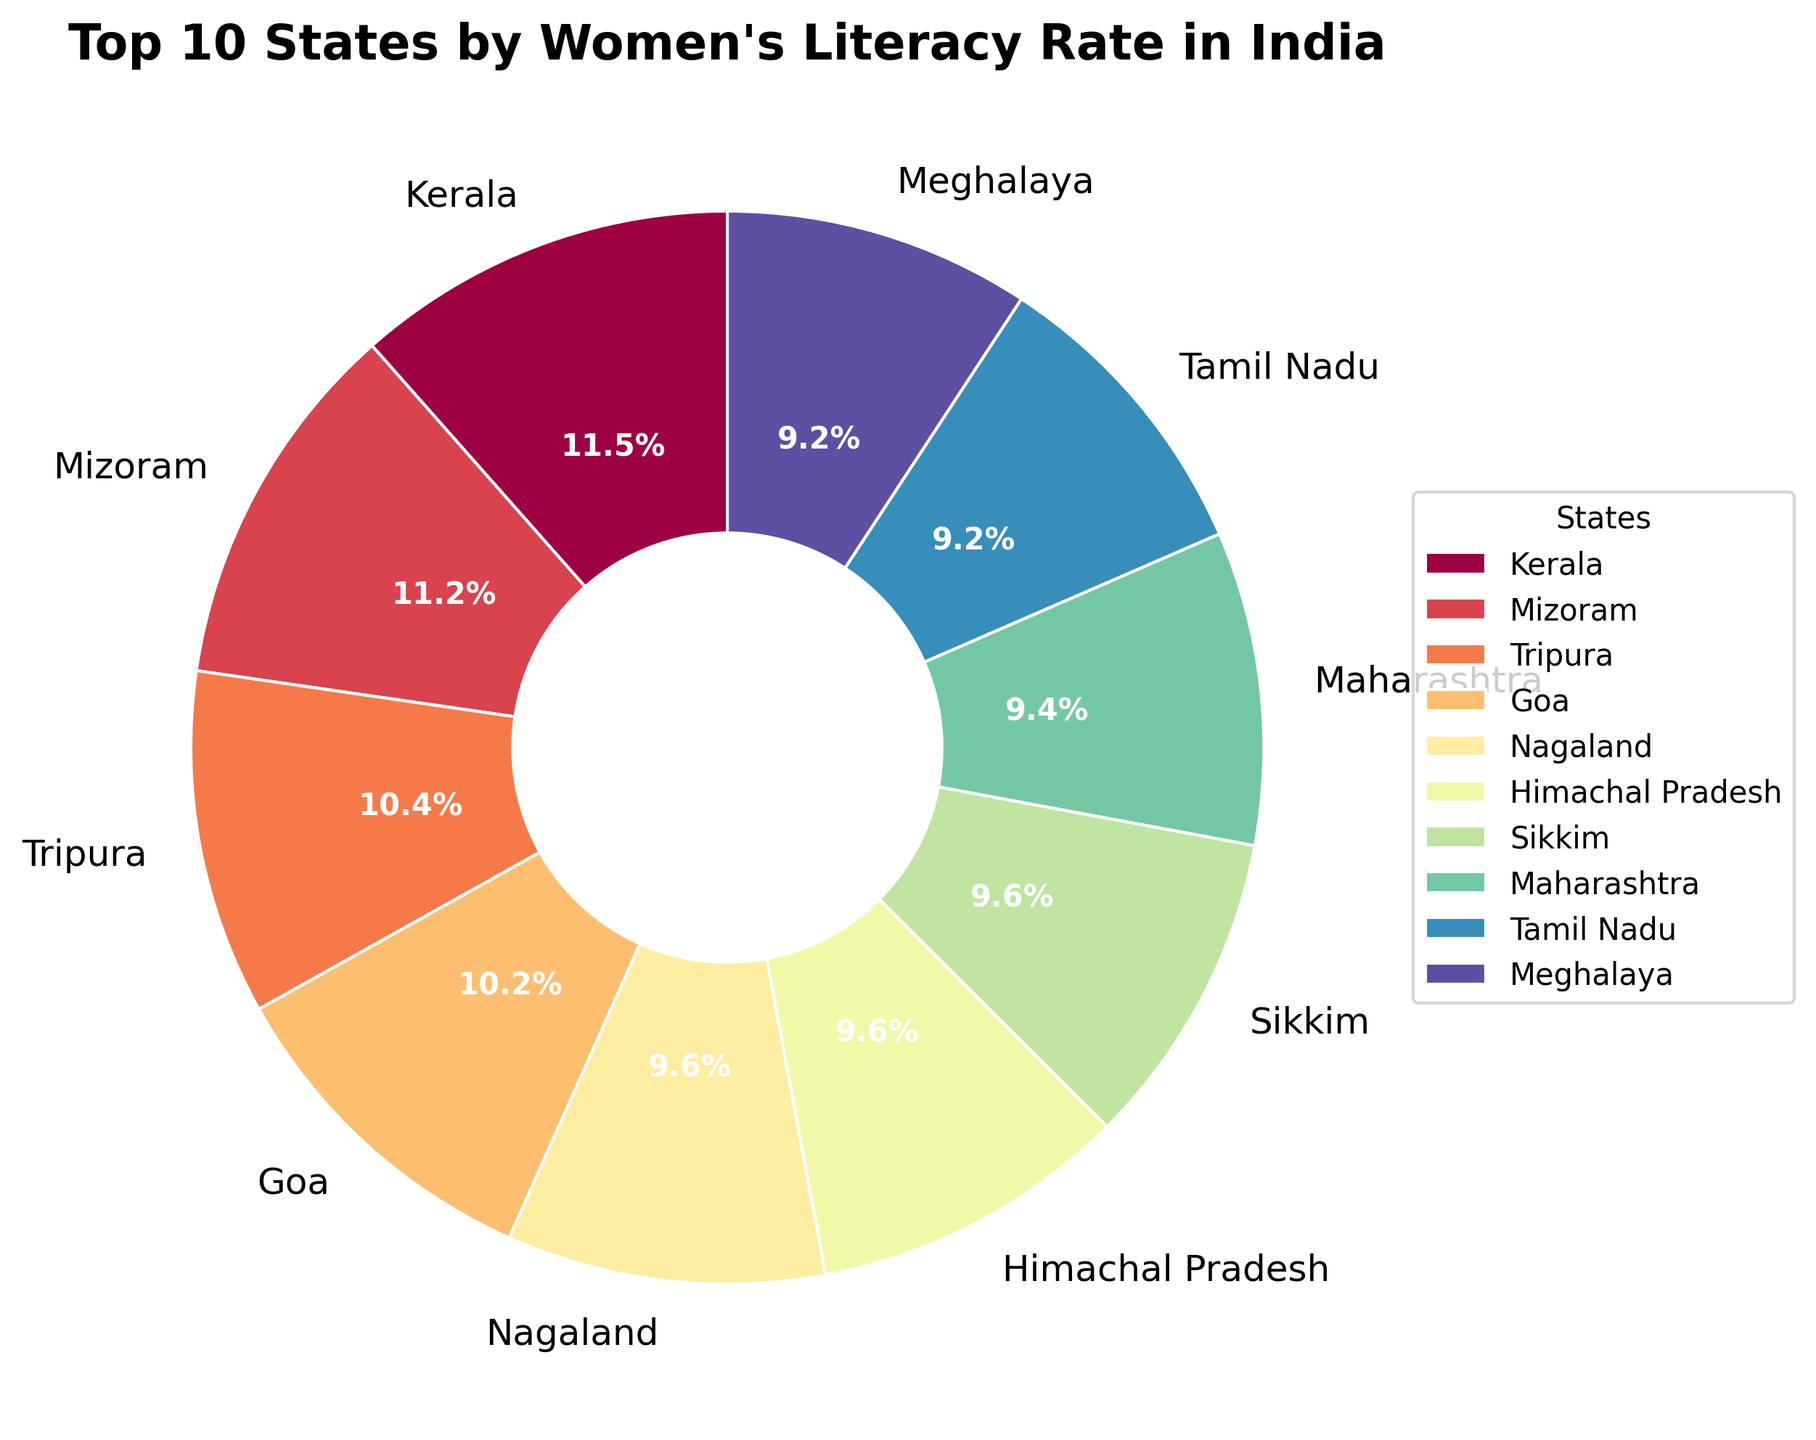Which state has the highest women's literacy rate? The state positioned first in the pie chart with the largest wedge represents the highest literacy rate. In this case, Kerala is shown at the top with the largest percentage.
Answer: Kerala What is the sum of women's literacy rates for Tripura and Goa? To find the sum, add the literacy rates of Tripura (83.1%) and Goa (81.8%). The calculation is 83.1 + 81.8.
Answer: 164.9% Which state has a higher women's literacy rate, Maharashtra or Tamil Nadu? By visually comparing the wedges labeled Maharashtra and Tamil Nadu, we see Maharashtra has a larger wedge, indicating a higher literacy rate.
Answer: Maharashtra What's the average women's literacy rate among the top 3 states? The top 3 states are Kerala (92.1%), Mizoram (89.4%), and Tripura (83.1%). To calculate the average, sum these rates and divide by 3: (92.1 + 89.4 + 83.1) / 3.
Answer: 88.2% How much greater is the women's literacy rate in Kerala compared to Rajasthan? Kerala's literacy rate is 92.1% and Rajasthan's is 52.7%. Subtract Rajasthan's rate from Kerala's: 92.1 - 52.7.
Answer: 39.4% Which states have nearly equal women's literacy rates? Visually scan for wedges of similar size. Maharashtra (75.5%) and Himachal Pradesh (76.6%) are close.
Answer: Maharashtra and Himachal Pradesh What is the percentage difference in women's literacy rates between the top state and the state with the smallest wedge among the top 10? Kerala (92.1%) has the highest rate. The smallest wedge among the top 10 belongs to Meghalaya (73.8%). Calculate the percentage difference: 92.1 - 73.8.
Answer: 18.3% How does the women's literacy rate of Karnataka compare to Telangana? Visually compare the wedges labeled Karnataka (68.1%) and Telangana (65.1%). Karnataka's wedge is larger, so its rate is higher.
Answer: Karnataka What's the combined percentage of women's literacy rates for Kerala, Mizoram, and Sikkim compared to the sum of the last three states in the top 10? The top three are Kerala (92.1%), Mizoram (89.4%), and Tripura (83.1%). Sum: 92.1+89.4+83.1=264.6. The last three are Manipur (73.2%), Meghalaya (73.8%), and Nagaland (76.7%). Sum: 73.2+73.8+76.7=223.7. Compare the sums: 264.6 is greater than 223.7.
Answer: 264.6% vs. 223.7% What is the visual cue for identifying the state with the second-highest women's literacy rate? The second-largest wedge identifies the state. After Kerala, the next largest wedge belongs to Mizoram.
Answer: Mizoram 